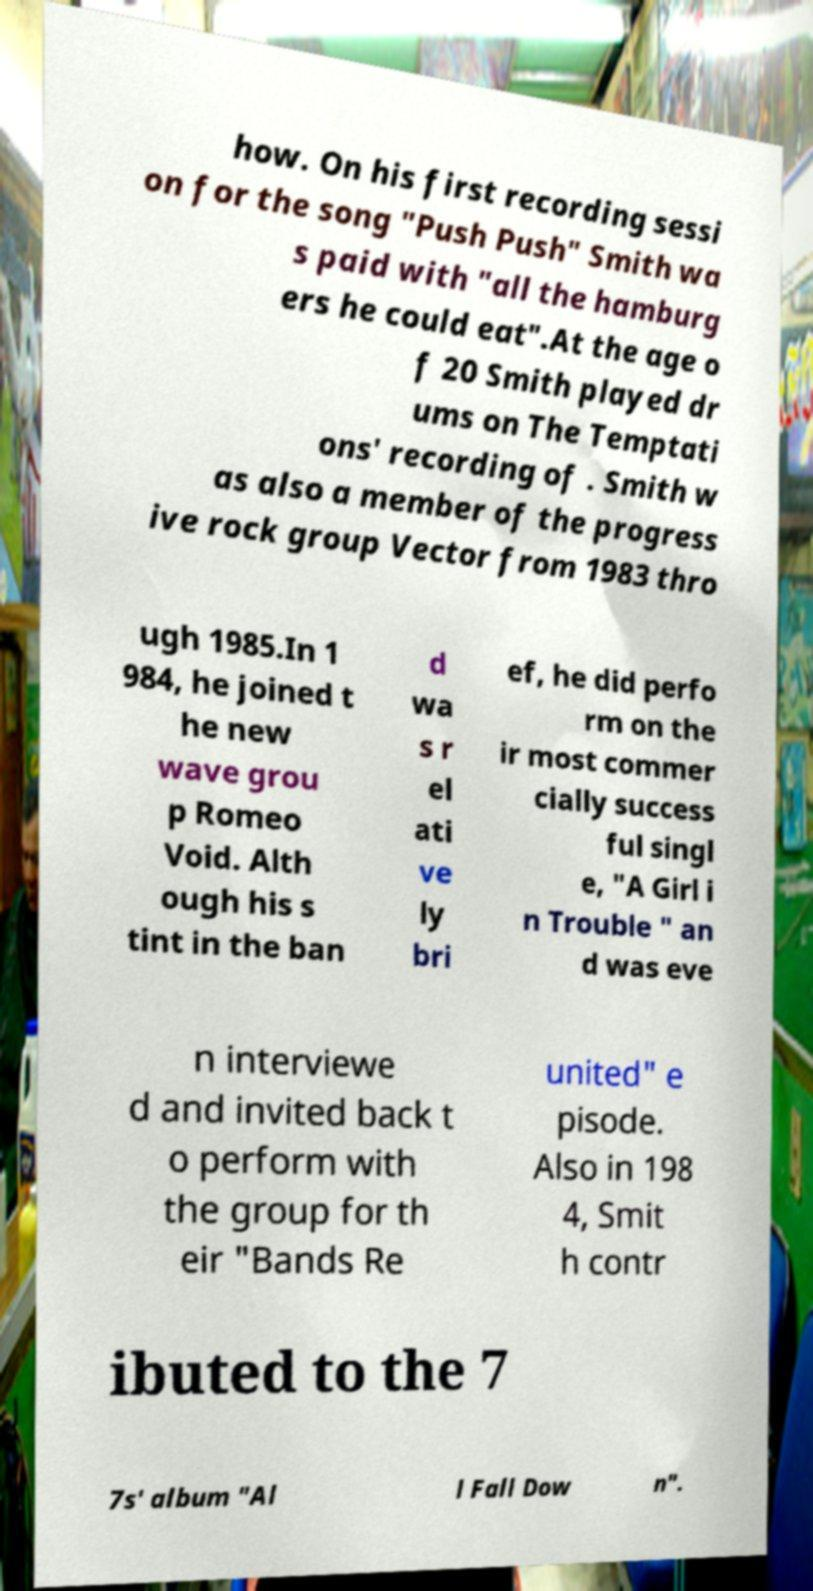There's text embedded in this image that I need extracted. Can you transcribe it verbatim? how. On his first recording sessi on for the song "Push Push" Smith wa s paid with "all the hamburg ers he could eat".At the age o f 20 Smith played dr ums on The Temptati ons' recording of . Smith w as also a member of the progress ive rock group Vector from 1983 thro ugh 1985.In 1 984, he joined t he new wave grou p Romeo Void. Alth ough his s tint in the ban d wa s r el ati ve ly bri ef, he did perfo rm on the ir most commer cially success ful singl e, "A Girl i n Trouble " an d was eve n interviewe d and invited back t o perform with the group for th eir "Bands Re united" e pisode. Also in 198 4, Smit h contr ibuted to the 7 7s' album "Al l Fall Dow n". 